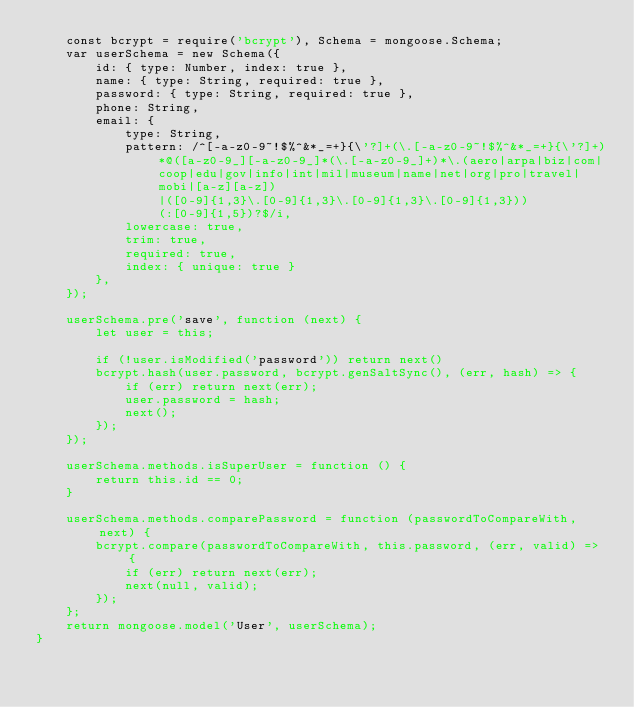<code> <loc_0><loc_0><loc_500><loc_500><_JavaScript_>    const bcrypt = require('bcrypt'), Schema = mongoose.Schema;
    var userSchema = new Schema({
        id: { type: Number, index: true },
        name: { type: String, required: true },
        password: { type: String, required: true },
        phone: String,
        email: {
            type: String,
            pattern: /^[-a-z0-9~!$%^&*_=+}{\'?]+(\.[-a-z0-9~!$%^&*_=+}{\'?]+)*@([a-z0-9_][-a-z0-9_]*(\.[-a-z0-9_]+)*\.(aero|arpa|biz|com|coop|edu|gov|info|int|mil|museum|name|net|org|pro|travel|mobi|[a-z][a-z])|([0-9]{1,3}\.[0-9]{1,3}\.[0-9]{1,3}\.[0-9]{1,3}))(:[0-9]{1,5})?$/i,
            lowercase: true,
            trim: true,
            required: true,
            index: { unique: true }
        },
    });

    userSchema.pre('save', function (next) {
        let user = this;

        if (!user.isModified('password')) return next()
        bcrypt.hash(user.password, bcrypt.genSaltSync(), (err, hash) => {
            if (err) return next(err);
            user.password = hash;
            next();
        });
    });

    userSchema.methods.isSuperUser = function () {
        return this.id == 0;
    }

    userSchema.methods.comparePassword = function (passwordToCompareWith, next) {
        bcrypt.compare(passwordToCompareWith, this.password, (err, valid) => {
            if (err) return next(err);
            next(null, valid);
        });
    };
    return mongoose.model('User', userSchema);
}</code> 